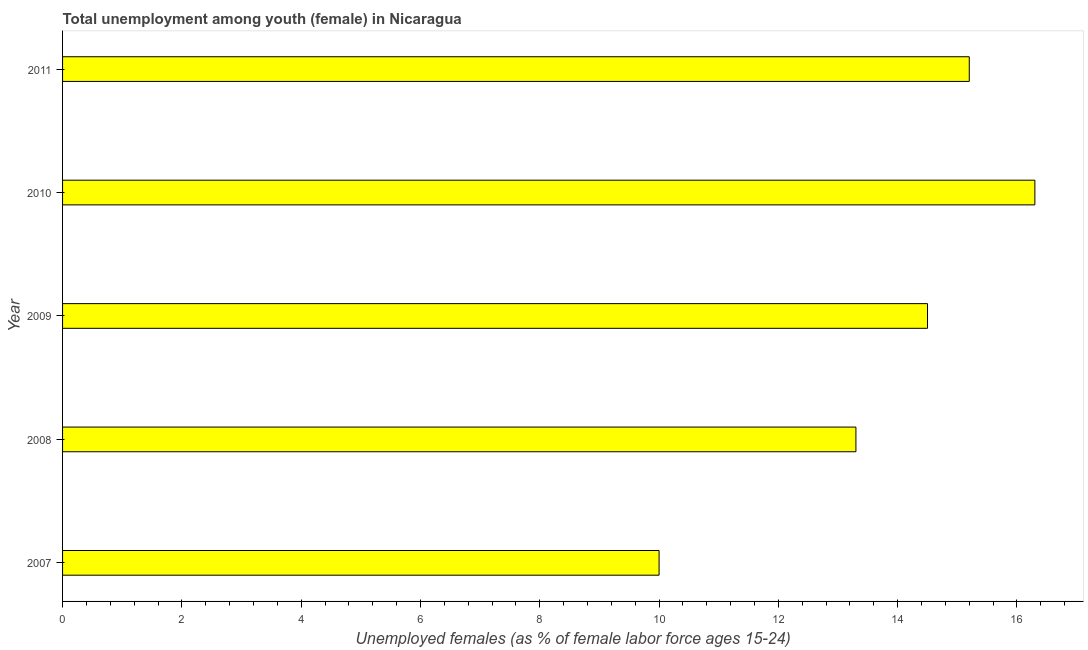Does the graph contain grids?
Provide a short and direct response. No. What is the title of the graph?
Offer a very short reply. Total unemployment among youth (female) in Nicaragua. What is the label or title of the X-axis?
Give a very brief answer. Unemployed females (as % of female labor force ages 15-24). What is the label or title of the Y-axis?
Provide a succinct answer. Year. What is the unemployed female youth population in 2010?
Ensure brevity in your answer.  16.3. Across all years, what is the maximum unemployed female youth population?
Your answer should be very brief. 16.3. Across all years, what is the minimum unemployed female youth population?
Offer a very short reply. 10. In which year was the unemployed female youth population minimum?
Provide a succinct answer. 2007. What is the sum of the unemployed female youth population?
Provide a short and direct response. 69.3. What is the average unemployed female youth population per year?
Provide a short and direct response. 13.86. What is the median unemployed female youth population?
Make the answer very short. 14.5. In how many years, is the unemployed female youth population greater than 15.6 %?
Provide a short and direct response. 1. Do a majority of the years between 2011 and 2007 (inclusive) have unemployed female youth population greater than 14.4 %?
Your answer should be very brief. Yes. What is the ratio of the unemployed female youth population in 2007 to that in 2008?
Your answer should be very brief. 0.75. Is the difference between the unemployed female youth population in 2008 and 2009 greater than the difference between any two years?
Ensure brevity in your answer.  No. What is the difference between the highest and the lowest unemployed female youth population?
Make the answer very short. 6.3. In how many years, is the unemployed female youth population greater than the average unemployed female youth population taken over all years?
Keep it short and to the point. 3. Are all the bars in the graph horizontal?
Offer a very short reply. Yes. What is the difference between two consecutive major ticks on the X-axis?
Your answer should be very brief. 2. Are the values on the major ticks of X-axis written in scientific E-notation?
Your response must be concise. No. What is the Unemployed females (as % of female labor force ages 15-24) of 2008?
Make the answer very short. 13.3. What is the Unemployed females (as % of female labor force ages 15-24) in 2009?
Provide a short and direct response. 14.5. What is the Unemployed females (as % of female labor force ages 15-24) in 2010?
Your answer should be compact. 16.3. What is the Unemployed females (as % of female labor force ages 15-24) of 2011?
Provide a short and direct response. 15.2. What is the difference between the Unemployed females (as % of female labor force ages 15-24) in 2007 and 2008?
Keep it short and to the point. -3.3. What is the difference between the Unemployed females (as % of female labor force ages 15-24) in 2007 and 2009?
Give a very brief answer. -4.5. What is the difference between the Unemployed females (as % of female labor force ages 15-24) in 2008 and 2009?
Make the answer very short. -1.2. What is the difference between the Unemployed females (as % of female labor force ages 15-24) in 2009 and 2011?
Your answer should be very brief. -0.7. What is the difference between the Unemployed females (as % of female labor force ages 15-24) in 2010 and 2011?
Offer a terse response. 1.1. What is the ratio of the Unemployed females (as % of female labor force ages 15-24) in 2007 to that in 2008?
Ensure brevity in your answer.  0.75. What is the ratio of the Unemployed females (as % of female labor force ages 15-24) in 2007 to that in 2009?
Your answer should be compact. 0.69. What is the ratio of the Unemployed females (as % of female labor force ages 15-24) in 2007 to that in 2010?
Ensure brevity in your answer.  0.61. What is the ratio of the Unemployed females (as % of female labor force ages 15-24) in 2007 to that in 2011?
Give a very brief answer. 0.66. What is the ratio of the Unemployed females (as % of female labor force ages 15-24) in 2008 to that in 2009?
Your answer should be very brief. 0.92. What is the ratio of the Unemployed females (as % of female labor force ages 15-24) in 2008 to that in 2010?
Give a very brief answer. 0.82. What is the ratio of the Unemployed females (as % of female labor force ages 15-24) in 2008 to that in 2011?
Provide a succinct answer. 0.88. What is the ratio of the Unemployed females (as % of female labor force ages 15-24) in 2009 to that in 2010?
Your answer should be compact. 0.89. What is the ratio of the Unemployed females (as % of female labor force ages 15-24) in 2009 to that in 2011?
Your answer should be very brief. 0.95. What is the ratio of the Unemployed females (as % of female labor force ages 15-24) in 2010 to that in 2011?
Make the answer very short. 1.07. 